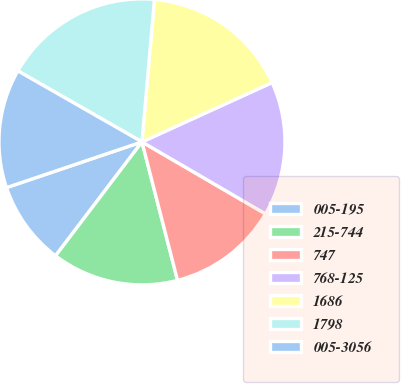Convert chart to OTSL. <chart><loc_0><loc_0><loc_500><loc_500><pie_chart><fcel>005-195<fcel>215-744<fcel>747<fcel>768-125<fcel>1686<fcel>1798<fcel>005-3056<nl><fcel>9.49%<fcel>14.33%<fcel>12.6%<fcel>15.21%<fcel>16.8%<fcel>18.12%<fcel>13.45%<nl></chart> 